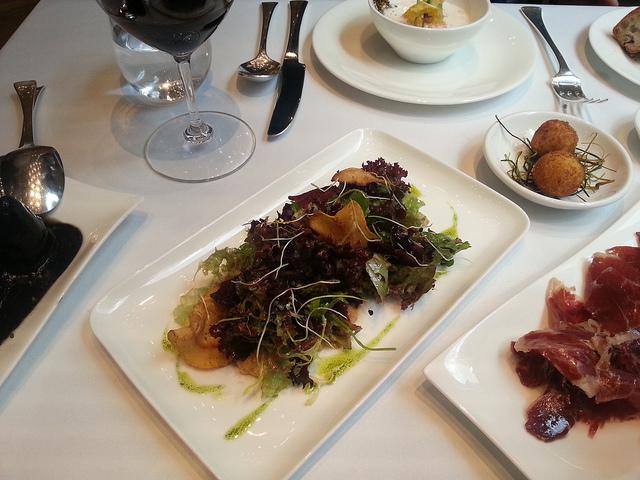Is the entree cold?
Keep it brief. Yes. How many spots of sauce are on the plate?
Write a very short answer. 0. How many spoons are on the table?
Give a very brief answer. 2. Can you drink wine from start?
Write a very short answer. Yes. 